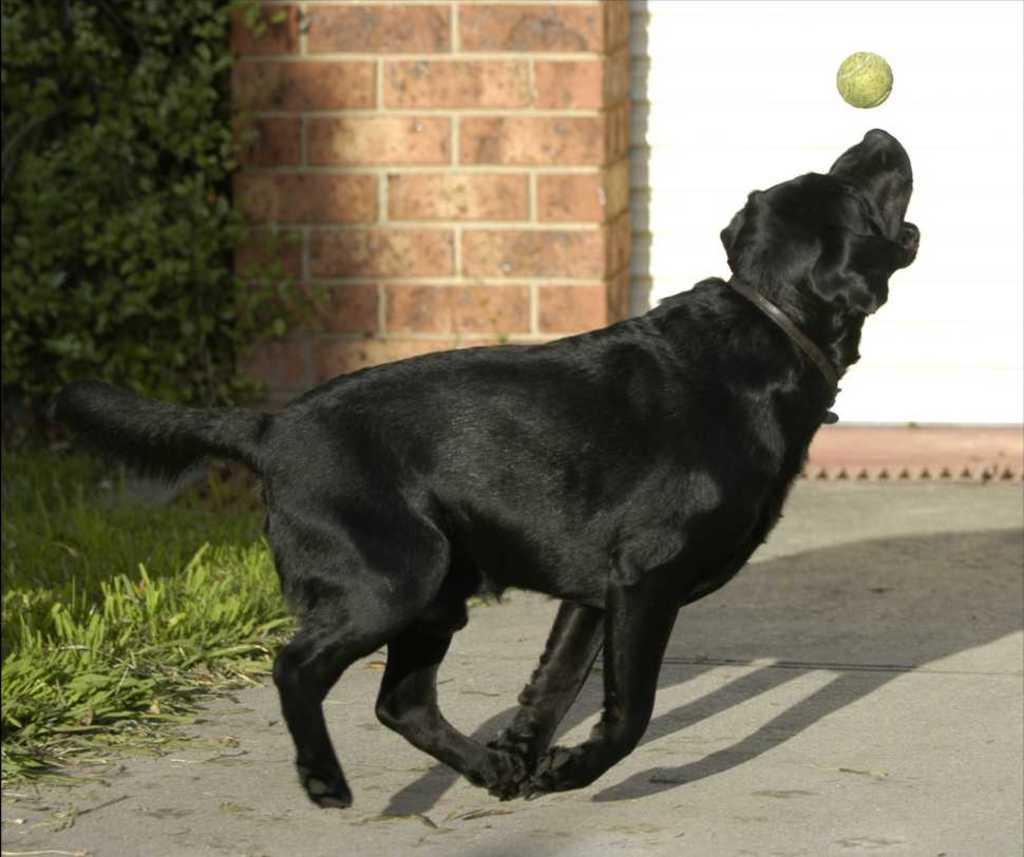What type of animal is present in the image? There is a dog in the image. What object is visible in the image that the dog might interact with? There is a ball in the image. What type of vegetation can be seen in the image? There are trees and grass in the image. What architectural feature is present in the image? There is a wall in the image. What part of the natural environment is visible in the image? The sky is visible in the image. Where are the bookshelves located in the image? There are no bookshelves present in the image. Can you describe the expert's opinion on the chair in the image? There is no expert or chair present in the image. 